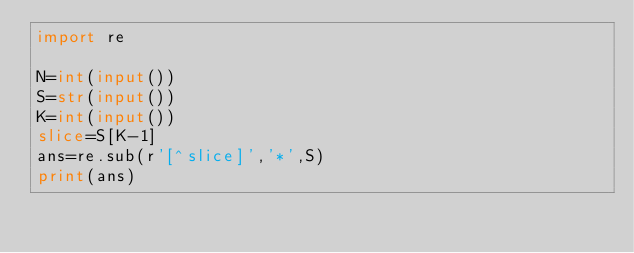<code> <loc_0><loc_0><loc_500><loc_500><_Python_>import re

N=int(input())
S=str(input())
K=int(input())
slice=S[K-1]
ans=re.sub(r'[^slice]','*',S)
print(ans)</code> 